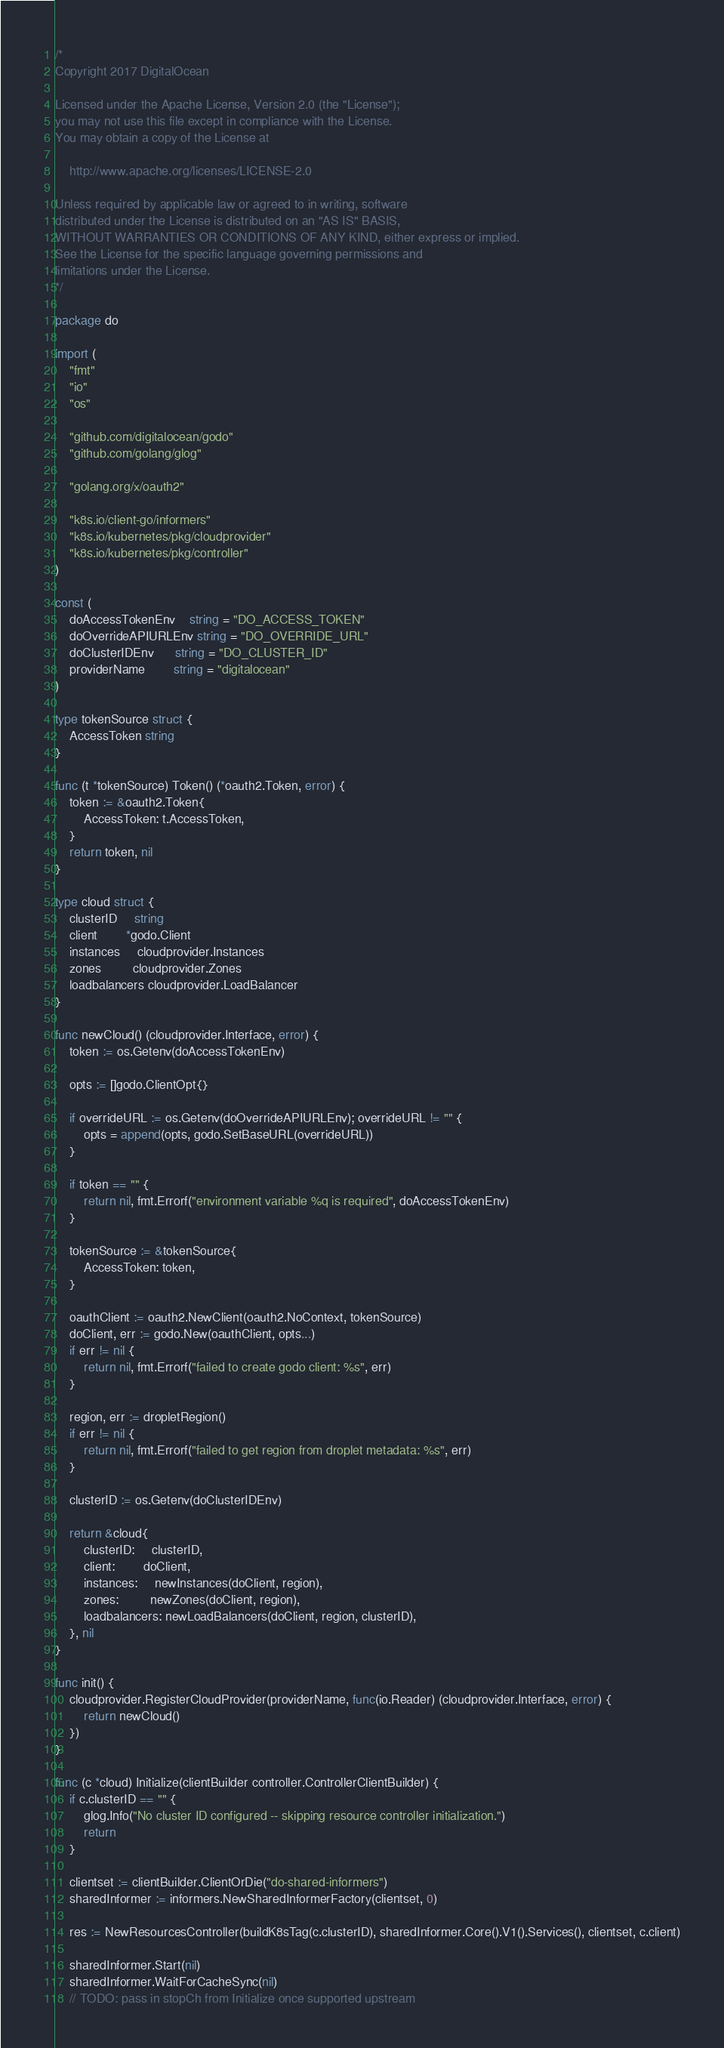Convert code to text. <code><loc_0><loc_0><loc_500><loc_500><_Go_>/*
Copyright 2017 DigitalOcean

Licensed under the Apache License, Version 2.0 (the "License");
you may not use this file except in compliance with the License.
You may obtain a copy of the License at

    http://www.apache.org/licenses/LICENSE-2.0

Unless required by applicable law or agreed to in writing, software
distributed under the License is distributed on an "AS IS" BASIS,
WITHOUT WARRANTIES OR CONDITIONS OF ANY KIND, either express or implied.
See the License for the specific language governing permissions and
limitations under the License.
*/

package do

import (
	"fmt"
	"io"
	"os"

	"github.com/digitalocean/godo"
	"github.com/golang/glog"

	"golang.org/x/oauth2"

	"k8s.io/client-go/informers"
	"k8s.io/kubernetes/pkg/cloudprovider"
	"k8s.io/kubernetes/pkg/controller"
)

const (
	doAccessTokenEnv    string = "DO_ACCESS_TOKEN"
	doOverrideAPIURLEnv string = "DO_OVERRIDE_URL"
	doClusterIDEnv      string = "DO_CLUSTER_ID"
	providerName        string = "digitalocean"
)

type tokenSource struct {
	AccessToken string
}

func (t *tokenSource) Token() (*oauth2.Token, error) {
	token := &oauth2.Token{
		AccessToken: t.AccessToken,
	}
	return token, nil
}

type cloud struct {
	clusterID     string
	client        *godo.Client
	instances     cloudprovider.Instances
	zones         cloudprovider.Zones
	loadbalancers cloudprovider.LoadBalancer
}

func newCloud() (cloudprovider.Interface, error) {
	token := os.Getenv(doAccessTokenEnv)

	opts := []godo.ClientOpt{}

	if overrideURL := os.Getenv(doOverrideAPIURLEnv); overrideURL != "" {
		opts = append(opts, godo.SetBaseURL(overrideURL))
	}

	if token == "" {
		return nil, fmt.Errorf("environment variable %q is required", doAccessTokenEnv)
	}

	tokenSource := &tokenSource{
		AccessToken: token,
	}

	oauthClient := oauth2.NewClient(oauth2.NoContext, tokenSource)
	doClient, err := godo.New(oauthClient, opts...)
	if err != nil {
		return nil, fmt.Errorf("failed to create godo client: %s", err)
	}

	region, err := dropletRegion()
	if err != nil {
		return nil, fmt.Errorf("failed to get region from droplet metadata: %s", err)
	}

	clusterID := os.Getenv(doClusterIDEnv)

	return &cloud{
		clusterID:     clusterID,
		client:        doClient,
		instances:     newInstances(doClient, region),
		zones:         newZones(doClient, region),
		loadbalancers: newLoadBalancers(doClient, region, clusterID),
	}, nil
}

func init() {
	cloudprovider.RegisterCloudProvider(providerName, func(io.Reader) (cloudprovider.Interface, error) {
		return newCloud()
	})
}

func (c *cloud) Initialize(clientBuilder controller.ControllerClientBuilder) {
	if c.clusterID == "" {
		glog.Info("No cluster ID configured -- skipping resource controller initialization.")
		return
	}

	clientset := clientBuilder.ClientOrDie("do-shared-informers")
	sharedInformer := informers.NewSharedInformerFactory(clientset, 0)

	res := NewResourcesController(buildK8sTag(c.clusterID), sharedInformer.Core().V1().Services(), clientset, c.client)

	sharedInformer.Start(nil)
	sharedInformer.WaitForCacheSync(nil)
	// TODO: pass in stopCh from Initialize once supported upstream</code> 